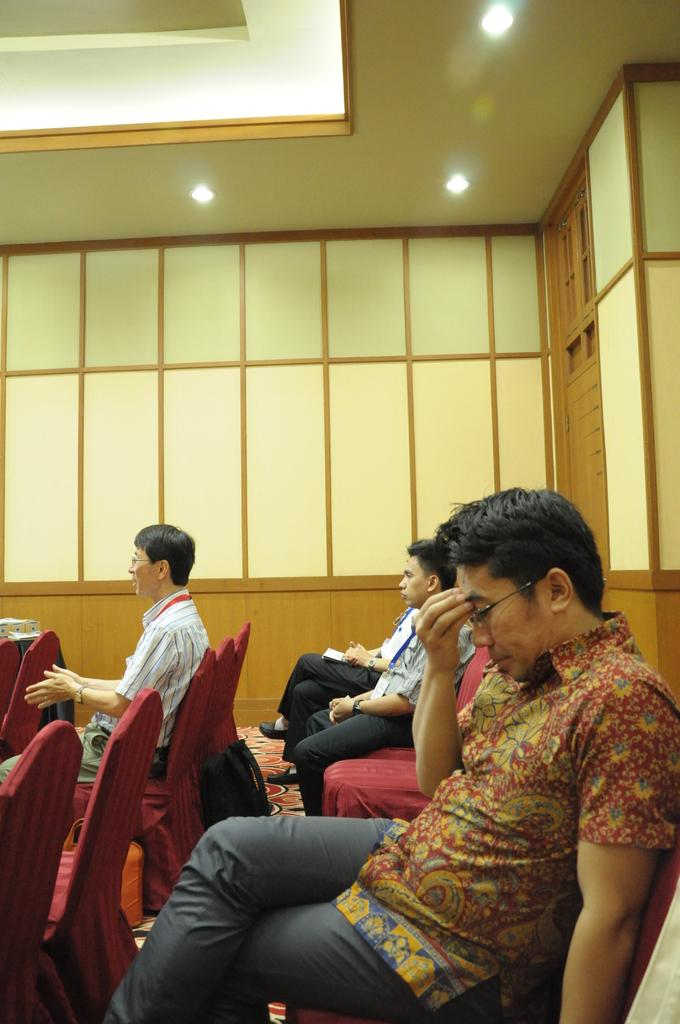What are the people in the image doing? The people in the image are sitting on chairs. What is attached to the wood wall in the image? There are glasses attached to the wood wall in the image. What can be seen above the people in the image? The ceiling with lights is visible in the image. What type of feather is being used as a decoration on the chairs in the image? There is no feather present as a decoration on the chairs in the image. What impulse might have led to the arrangement of the glasses on the wood wall? The arrangement of the glasses on the wood wall is not related to any impulse; it is simply a design choice. 